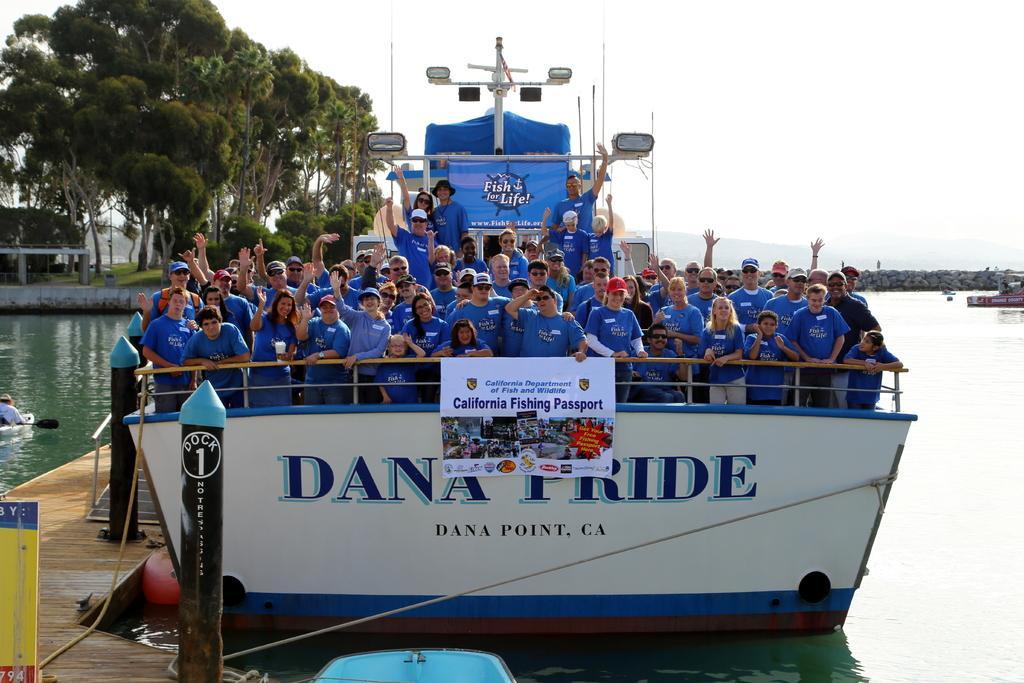Describe this image in one or two sentences. In this picture I can see group of people standing on the boat, which is on the water, there is a banner, there is a person sitting on the boat and holding a paddle, there is a wooden pier, there are trees, rocks, and in the background there is the sky. 